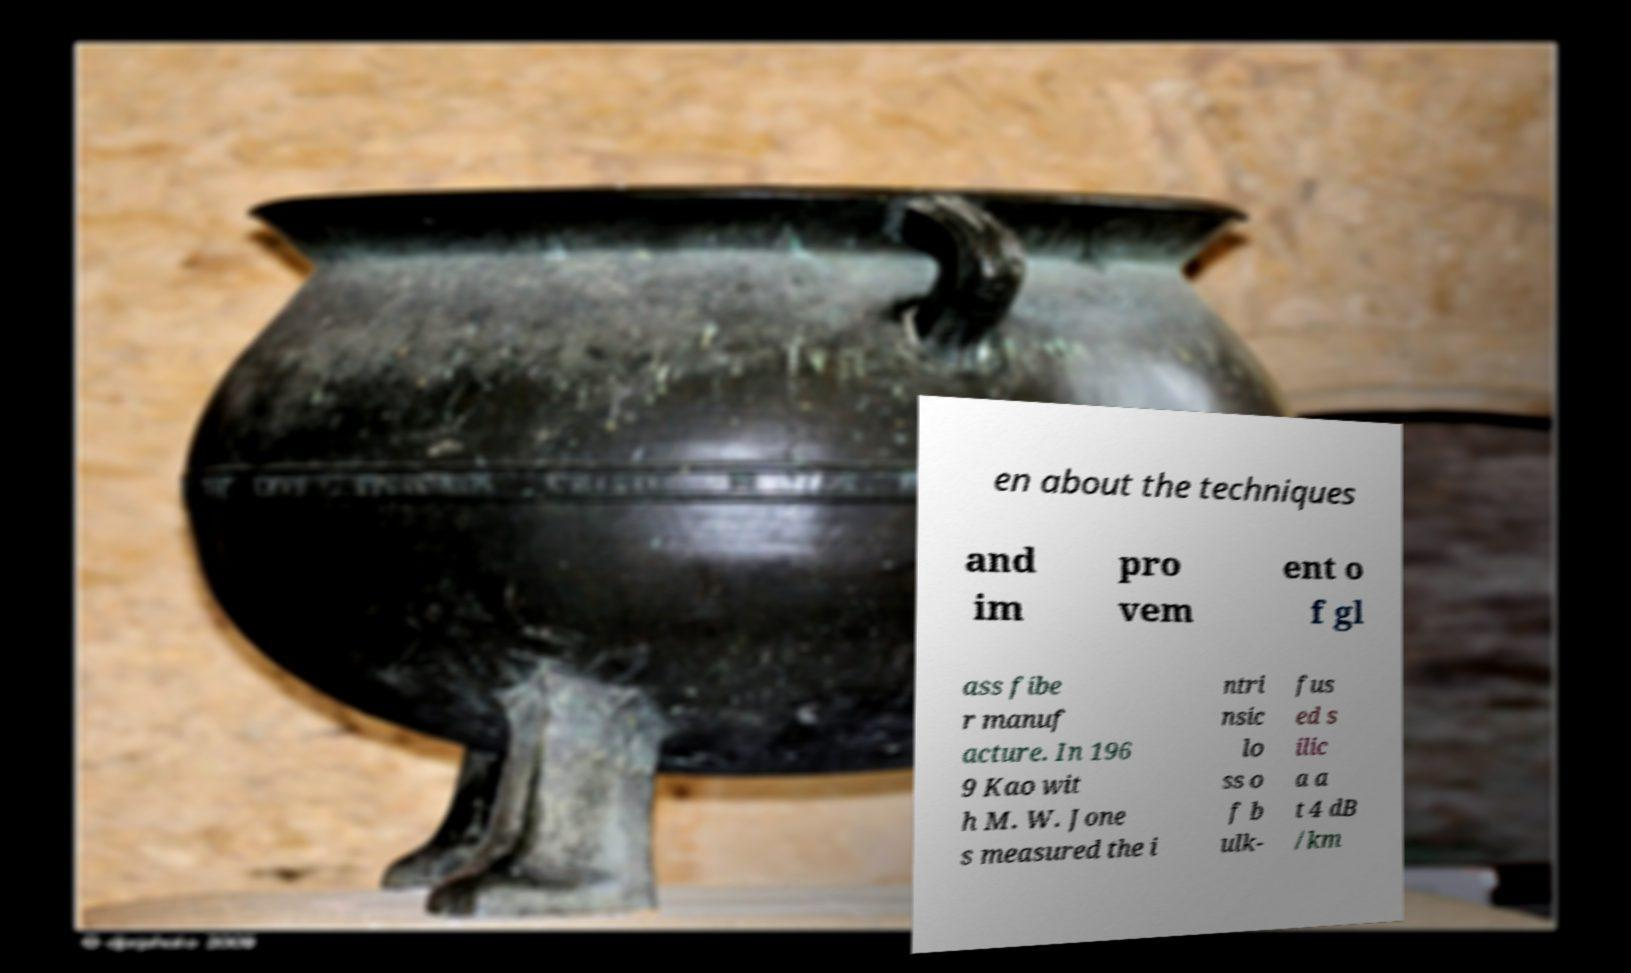Please read and relay the text visible in this image. What does it say? en about the techniques and im pro vem ent o f gl ass fibe r manuf acture. In 196 9 Kao wit h M. W. Jone s measured the i ntri nsic lo ss o f b ulk- fus ed s ilic a a t 4 dB /km 